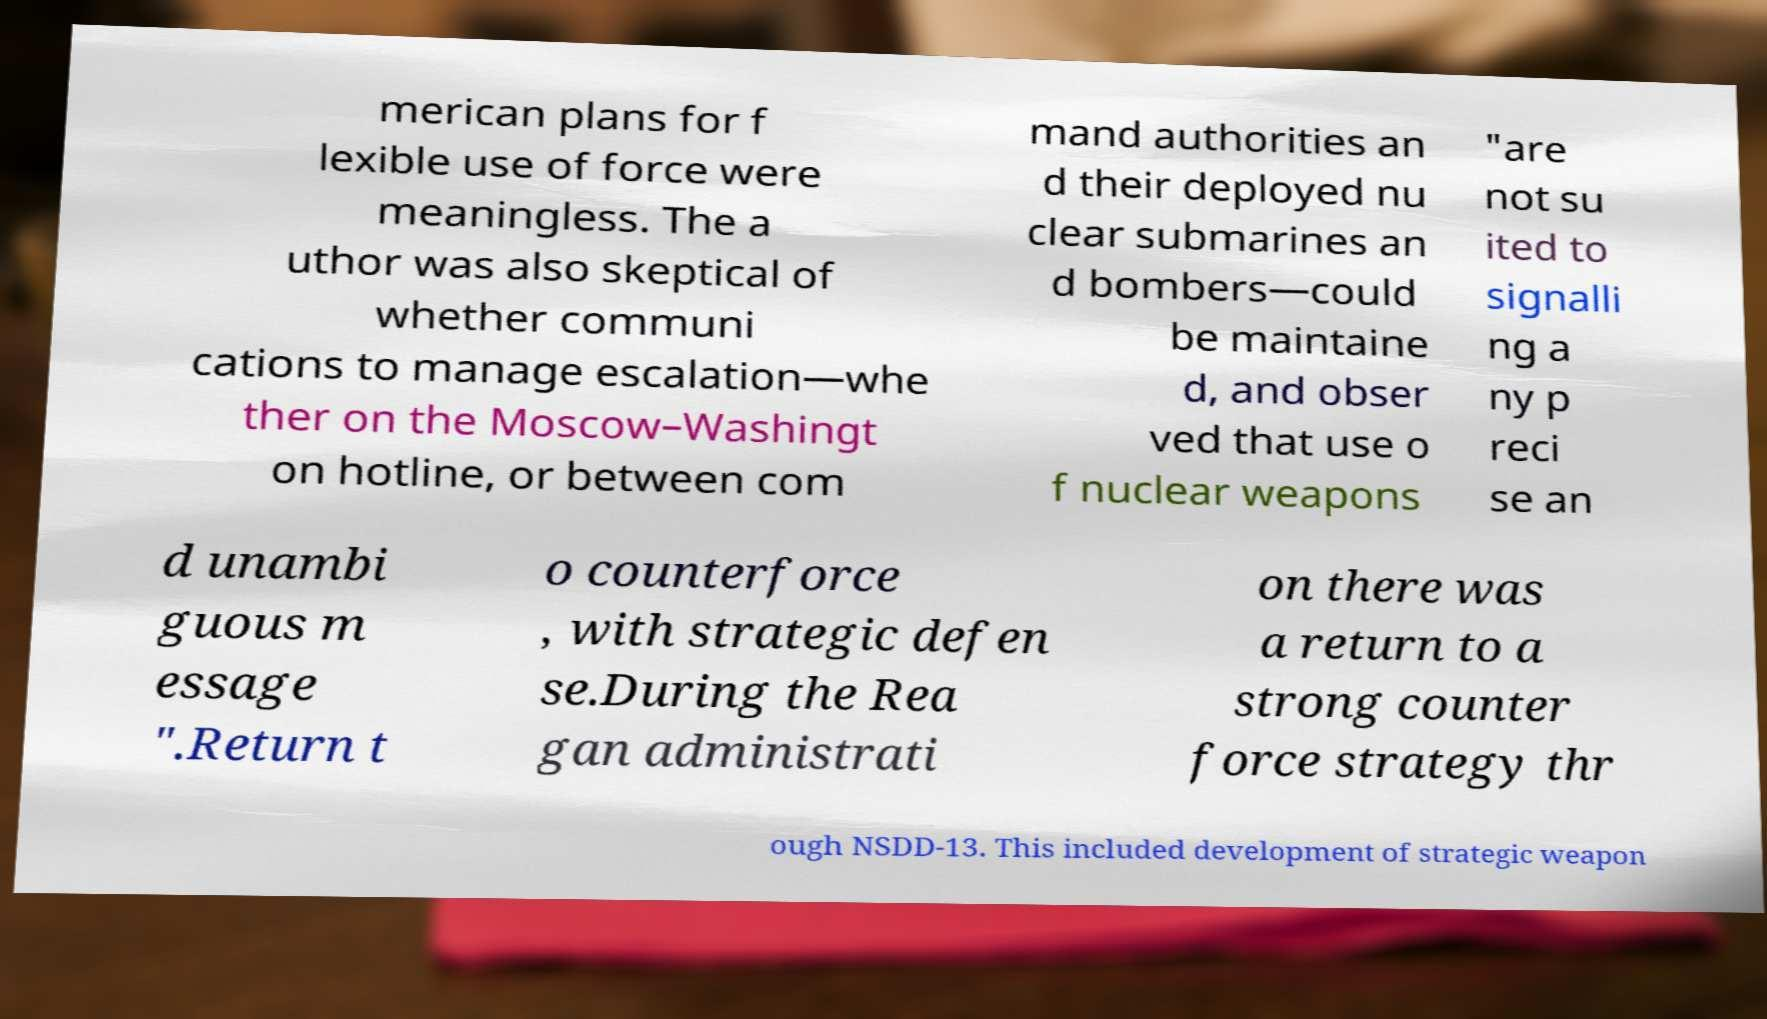Could you extract and type out the text from this image? merican plans for f lexible use of force were meaningless. The a uthor was also skeptical of whether communi cations to manage escalation—whe ther on the Moscow–Washingt on hotline, or between com mand authorities an d their deployed nu clear submarines an d bombers—could be maintaine d, and obser ved that use o f nuclear weapons "are not su ited to signalli ng a ny p reci se an d unambi guous m essage ".Return t o counterforce , with strategic defen se.During the Rea gan administrati on there was a return to a strong counter force strategy thr ough NSDD-13. This included development of strategic weapon 